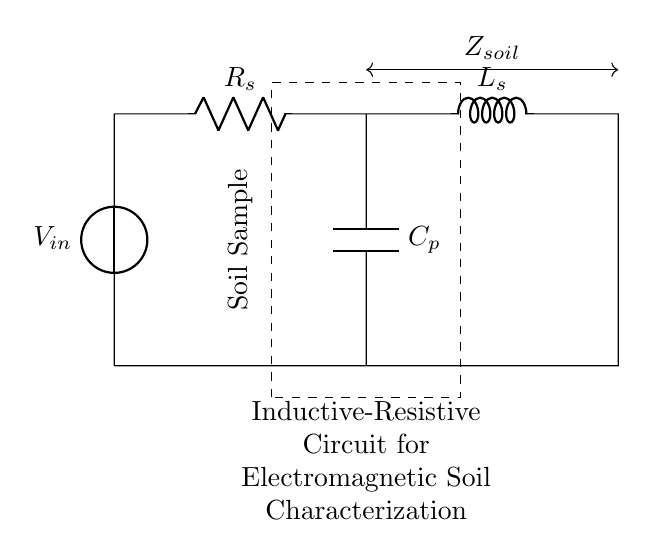What is the voltage source in this circuit? The voltage source is labeled as V_in in the circuit diagram, which supplies electrical power to the components.
Answer: V_in What type of components are used in this circuit? The circuit diagram includes a voltage source, a resistor (R_s), an inductor (L_s), and a capacitor (C_p), which are essential elements in RLC circuits.
Answer: Voltage source, resistor, inductor, capacitor What is the purpose of the soil sample rectangle in the diagram? The dashed rectangle indicates the area where the soil sample is situated, indicating that the circuit interacts with the soil for characterization purposes.
Answer: Soil characterization What are the components in series with the voltage source? The components in series with the voltage source consist of the resistor (R_s) and the inductor (L_s) connected in series.
Answer: Resistor, inductor What is the impedance of the soil represented by in this circuit? The impedance that the soil presents to the circuit is represented as Z_soil, which shows how the soil interacts with the electrical circuit.
Answer: Z_soil What happens to the circuit when the capacitor is charged? When the capacitor is charged, it stores electrical energy, which affects the overall impedance and can alter the current flowing through the circuit until it reaches a steady state.
Answer: Stores energy, alters current How does the inductor affect the circuit's response to varying frequencies? The inductor impedes the flow of alternating current depending on the frequency; higher frequencies result in greater inductive reactance, affecting the circuit's response and behavior in electromagnetic characterization.
Answer: Affects reactance frequency 